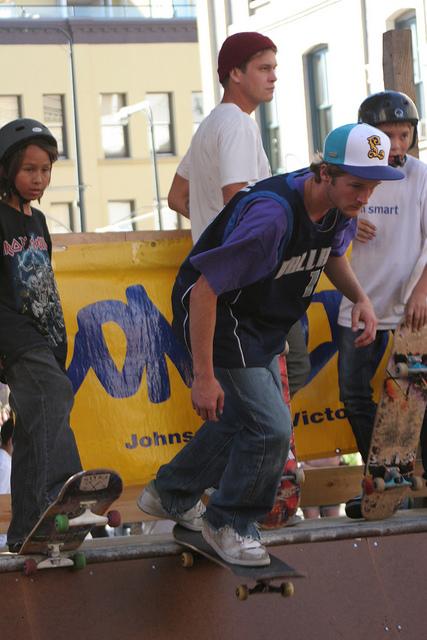Is everyone admiring the skaters?
Give a very brief answer. No. What color is this mans Jersey?
Keep it brief. Blue. How many people are wearing helmets?
Concise answer only. 2. How many kids are wearing helmets?
Quick response, please. 2. 